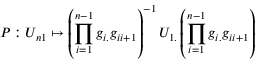<formula> <loc_0><loc_0><loc_500><loc_500>P \colon U _ { n 1 } \mapsto \left ( \prod _ { i = 1 } ^ { n - 1 } g _ { i . } g _ { i i + 1 } \right ) ^ { - 1 } U _ { 1 . } \left ( \prod _ { i = 1 } ^ { n - 1 } g _ { i . } g _ { i i + 1 } \right )</formula> 